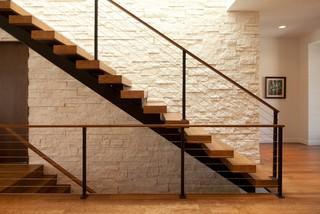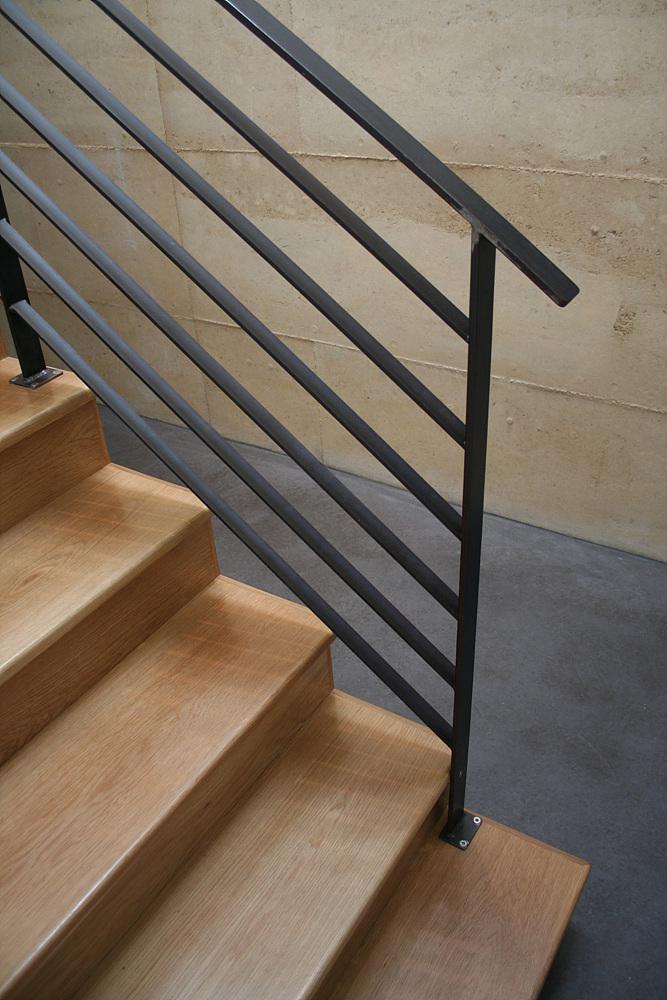The first image is the image on the left, the second image is the image on the right. Considering the images on both sides, is "The right image contains a staircase with a black handrail." valid? Answer yes or no. Yes. The first image is the image on the left, the second image is the image on the right. Assess this claim about the two images: "One image shows a diagonal 'floating' staircase in front of a brick-like wall and over an open stairwell.". Correct or not? Answer yes or no. Yes. 